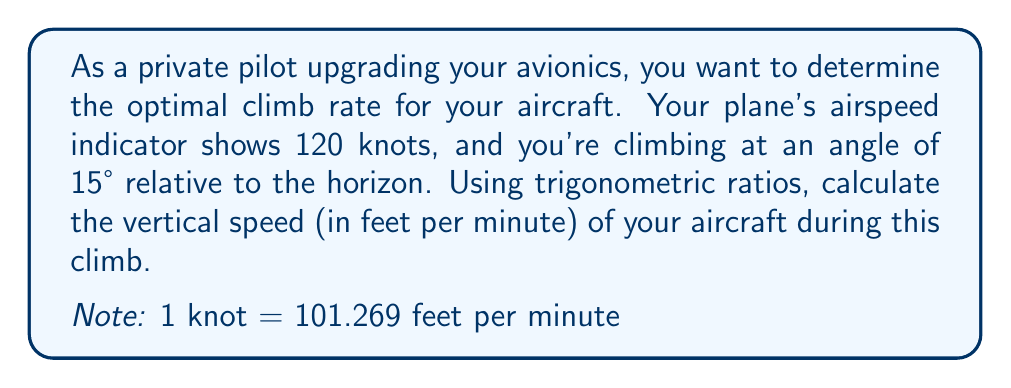Help me with this question. To solve this problem, we'll use the following steps:

1. Visualize the situation:
   [asy]
   import geometry;
   
   size(200);
   
   pair A = (0,0);
   pair B = (100,0);
   pair C = (100,26.79);
   
   draw(A--B--C--A);
   
   label("120 knots", (50,-5), S);
   label("15°", A, SW);
   label("Vertical Speed", (105,13), E);
   
   draw(arc(A,10,0,15), arrow=Arrow(TeXHead));
   [/asy]

2. Identify the trigonometric ratio to use:
   We need to find the vertical component of the velocity, which corresponds to the sine of the angle.

3. Set up the equation:
   $\text{Vertical Speed} = \text{Airspeed} \times \sin(\text{Climb Angle})$

4. Convert airspeed from knots to feet per minute:
   $120 \text{ knots} \times 101.269 \frac{\text{ft/min}}{\text{knot}} = 12,152.28 \text{ ft/min}$

5. Calculate the vertical speed:
   $\text{Vertical Speed} = 12,152.28 \times \sin(15°)$

6. Solve:
   $\text{Vertical Speed} = 12,152.28 \times 0.2588 = 3,145.01 \text{ ft/min}$

7. Round to the nearest whole number:
   $\text{Vertical Speed} \approx 3,145 \text{ ft/min}$
Answer: 3,145 ft/min 